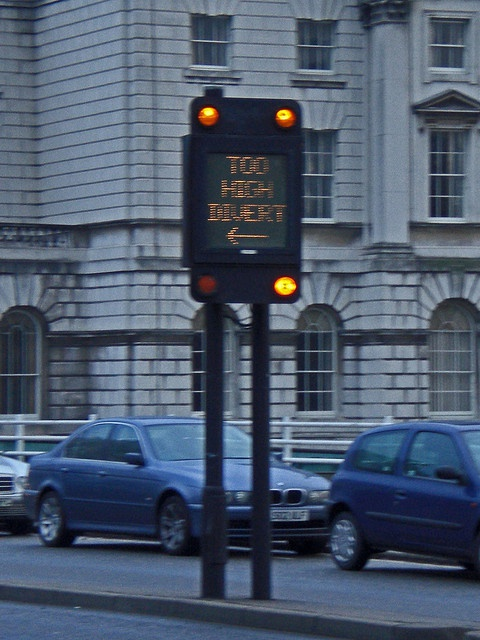Describe the objects in this image and their specific colors. I can see car in black, navy, and gray tones, traffic light in black, maroon, and gray tones, car in black, navy, and blue tones, and car in black, lightblue, and navy tones in this image. 